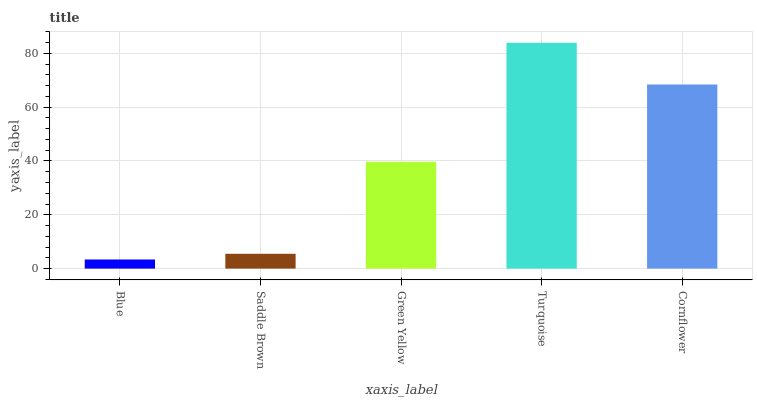Is Saddle Brown the minimum?
Answer yes or no. No. Is Saddle Brown the maximum?
Answer yes or no. No. Is Saddle Brown greater than Blue?
Answer yes or no. Yes. Is Blue less than Saddle Brown?
Answer yes or no. Yes. Is Blue greater than Saddle Brown?
Answer yes or no. No. Is Saddle Brown less than Blue?
Answer yes or no. No. Is Green Yellow the high median?
Answer yes or no. Yes. Is Green Yellow the low median?
Answer yes or no. Yes. Is Saddle Brown the high median?
Answer yes or no. No. Is Blue the low median?
Answer yes or no. No. 